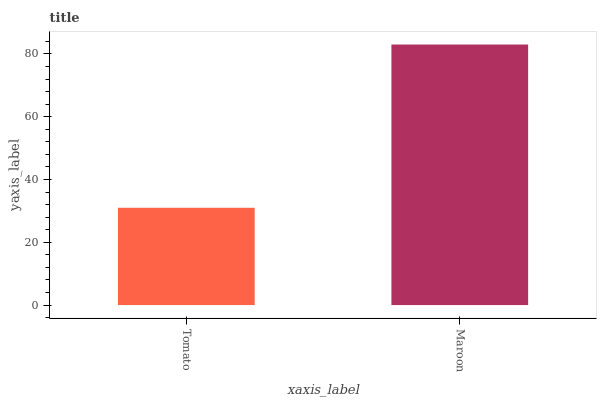Is Tomato the minimum?
Answer yes or no. Yes. Is Maroon the maximum?
Answer yes or no. Yes. Is Maroon the minimum?
Answer yes or no. No. Is Maroon greater than Tomato?
Answer yes or no. Yes. Is Tomato less than Maroon?
Answer yes or no. Yes. Is Tomato greater than Maroon?
Answer yes or no. No. Is Maroon less than Tomato?
Answer yes or no. No. Is Maroon the high median?
Answer yes or no. Yes. Is Tomato the low median?
Answer yes or no. Yes. Is Tomato the high median?
Answer yes or no. No. Is Maroon the low median?
Answer yes or no. No. 